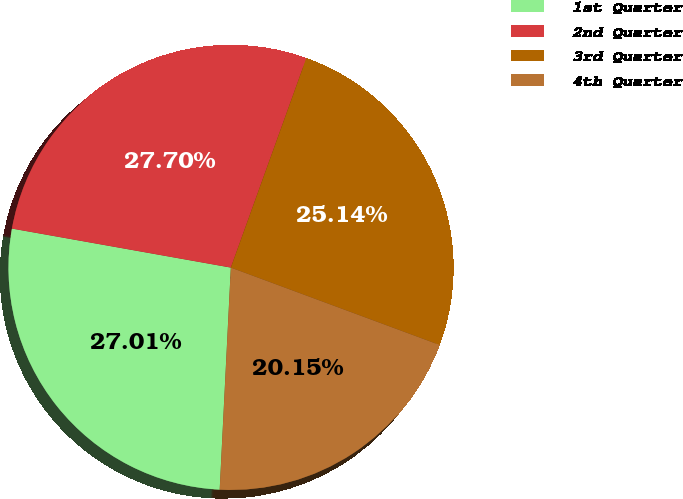Convert chart. <chart><loc_0><loc_0><loc_500><loc_500><pie_chart><fcel>1st Quarter<fcel>2nd Quarter<fcel>3rd Quarter<fcel>4th Quarter<nl><fcel>27.01%<fcel>27.7%<fcel>25.14%<fcel>20.15%<nl></chart> 